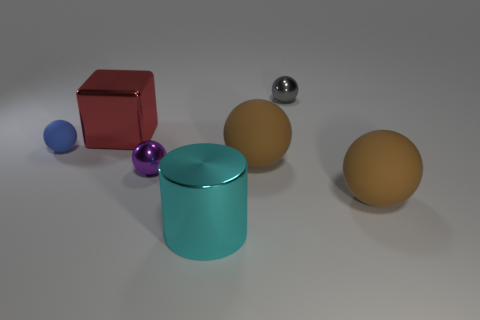How many large things are either gray metallic objects or brown rubber things?
Offer a very short reply. 2. There is a metallic thing that is behind the big cyan metal object and in front of the small rubber object; how big is it?
Offer a terse response. Small. There is a big red metallic block; what number of small purple objects are on the left side of it?
Ensure brevity in your answer.  0. The object that is right of the blue rubber sphere and on the left side of the tiny purple shiny object has what shape?
Offer a very short reply. Cube. What number of spheres are purple objects or red things?
Your answer should be compact. 1. Are there fewer brown spheres that are behind the gray object than cyan metal cylinders?
Your answer should be very brief. Yes. There is a small sphere that is right of the tiny blue ball and in front of the small gray thing; what is its color?
Your answer should be compact. Purple. What number of other objects are the same shape as the tiny blue object?
Make the answer very short. 4. Is the number of tiny balls that are to the left of the big red shiny block less than the number of large things on the right side of the big cyan cylinder?
Ensure brevity in your answer.  Yes. Do the big cylinder and the ball behind the tiny blue ball have the same material?
Your answer should be compact. Yes. 